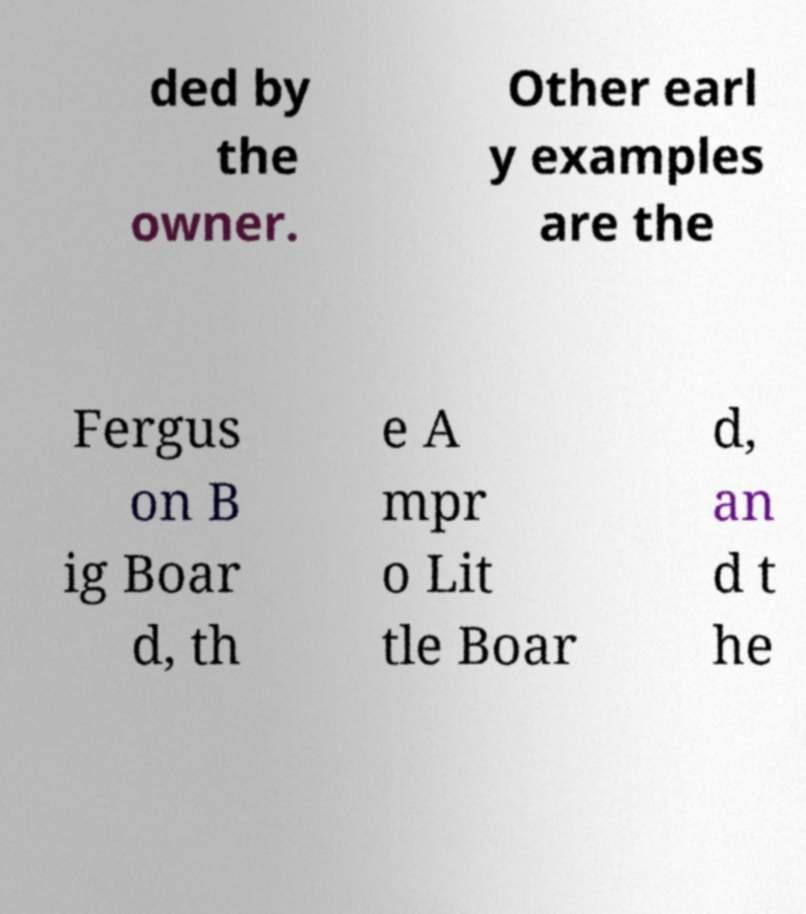Can you accurately transcribe the text from the provided image for me? ded by the owner. Other earl y examples are the Fergus on B ig Boar d, th e A mpr o Lit tle Boar d, an d t he 